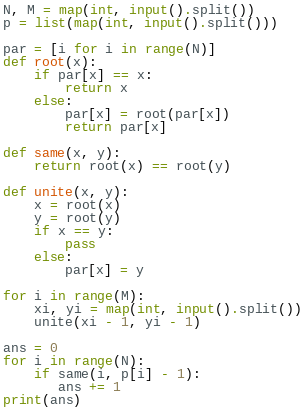Convert code to text. <code><loc_0><loc_0><loc_500><loc_500><_Python_>N, M = map(int, input().split())
p = list(map(int, input().split()))

par = [i for i in range(N)]
def root(x):
    if par[x] == x:
        return x
    else:
        par[x] = root(par[x])
        return par[x]

def same(x, y):
    return root(x) == root(y)

def unite(x, y):
    x = root(x)
    y = root(y)
    if x == y:
        pass
    else:
        par[x] = y

for i in range(M):
    xi, yi = map(int, input().split())
    unite(xi - 1, yi - 1)

ans = 0
for i in range(N):
    if same(i, p[i] - 1):
       ans += 1
print(ans)</code> 